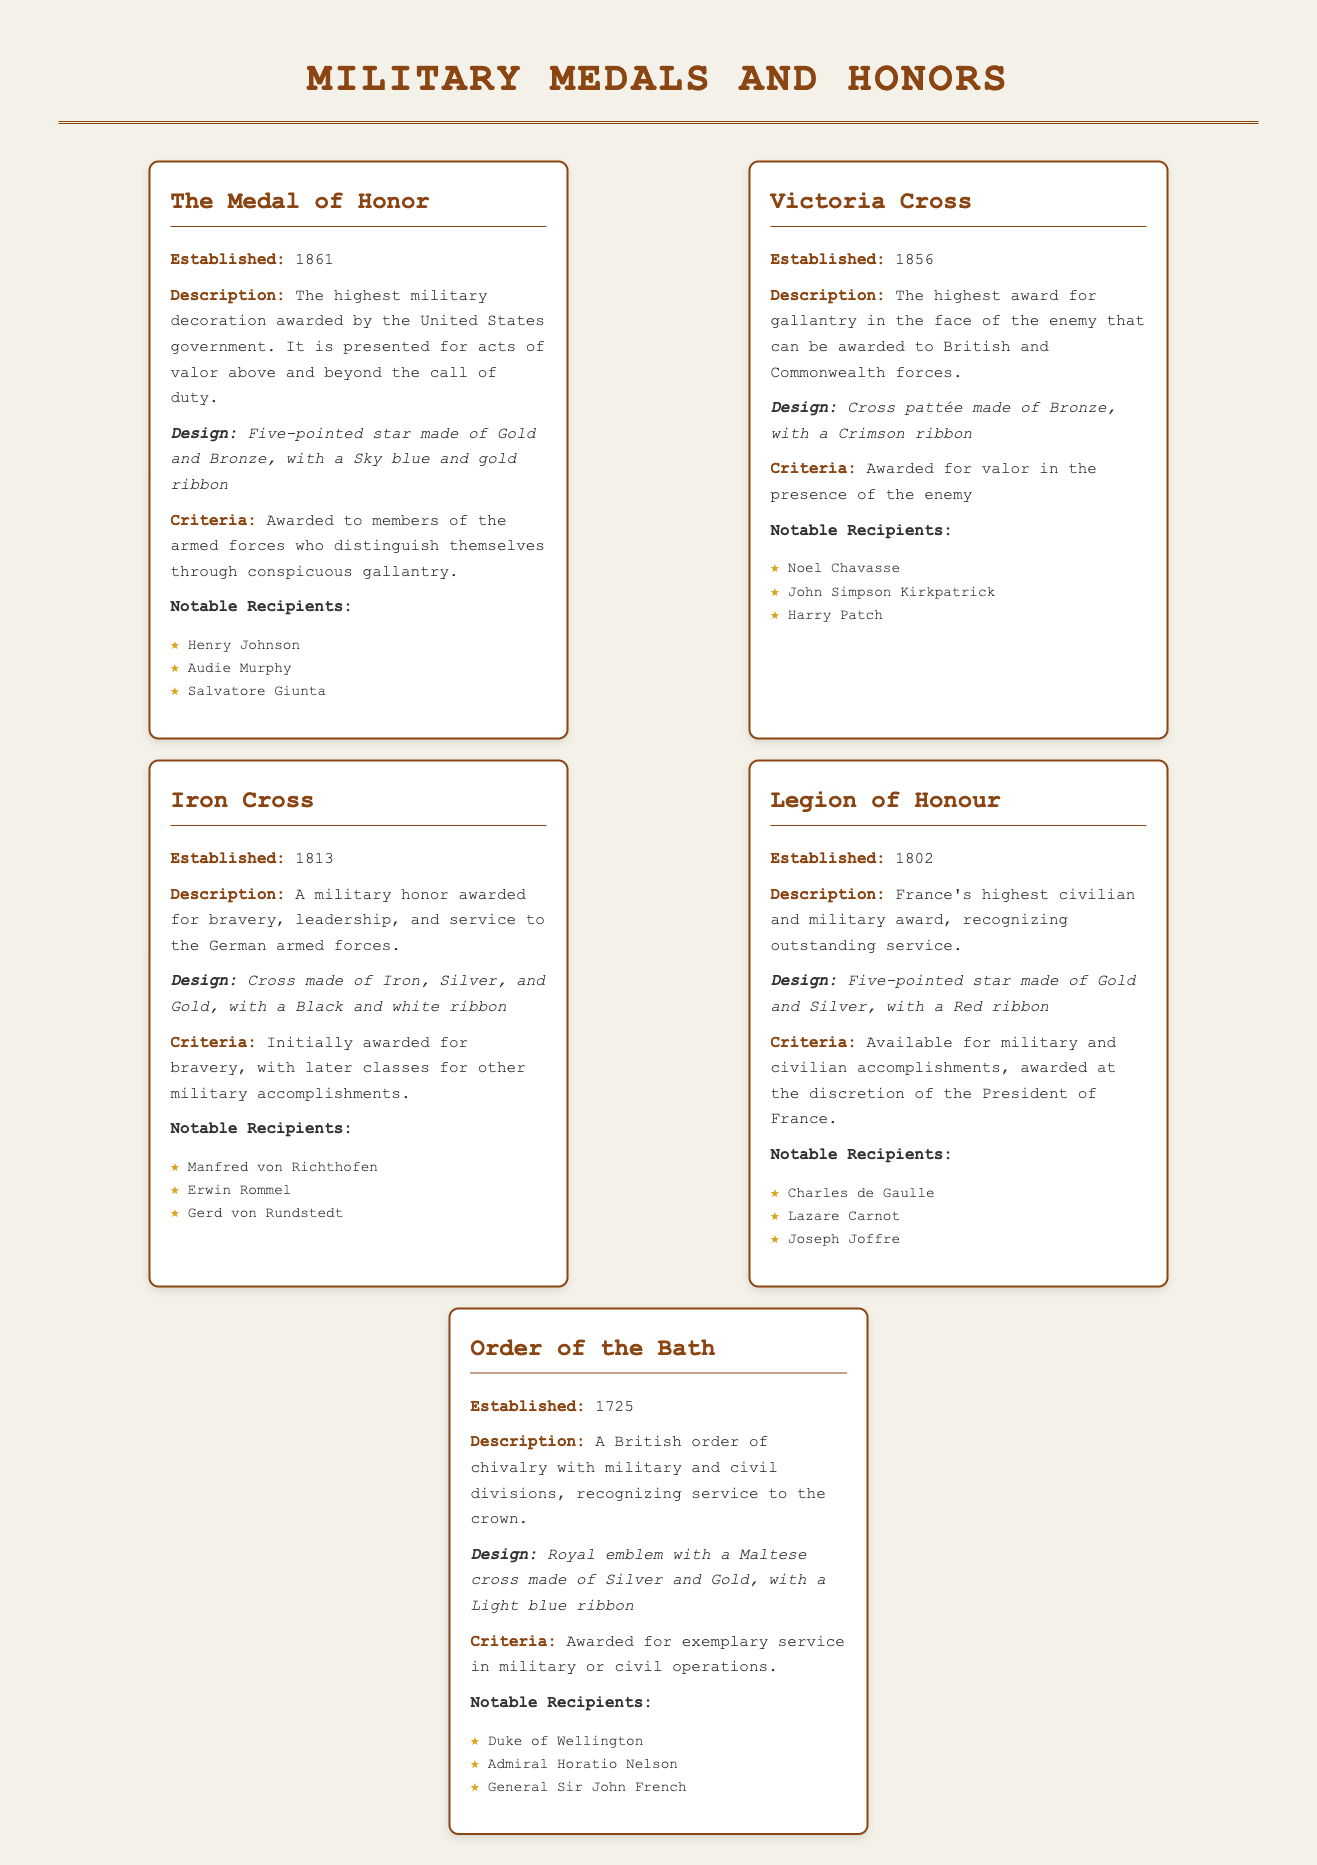What is the highest military decoration awarded by the United States government? According to the document, the highest military decoration is the Medal of Honor.
Answer: Medal of Honor When was the Victoria Cross established? The document states that the Victoria Cross was established in 1856.
Answer: 1856 What is the design of the Legion of Honour? The Legion of Honour is described as a five-pointed star made of Gold and Silver, with a Red ribbon.
Answer: Five-pointed star made of Gold and Silver, with a Red ribbon Who received the Iron Cross? The document lists notable recipients of the Iron Cross, which includes Manfred von Richthofen.
Answer: Manfred von Richthofen What criteria must be met to earn the Order of the Bath? The Order of the Bath is awarded for exemplary service in military or civil operations.
Answer: Exemplary service in military or civil operations Which medal recognizes outstanding service in both military and civilian capacities? The document specifies that the Legion of Honour recognizes outstanding service in military and civilian capacities.
Answer: Legion of Honour How is the Iron Cross described? The Iron Cross is described as a military honor awarded for bravery, leadership, and service.
Answer: A military honor awarded for bravery, leadership, and service What color ribbon is associated with the Victoria Cross? The document indicates that the ribbon for the Victoria Cross is Crimson.
Answer: Crimson When was the Medal of Honor established? The document notes that the Medal of Honor was established in 1861.
Answer: 1861 